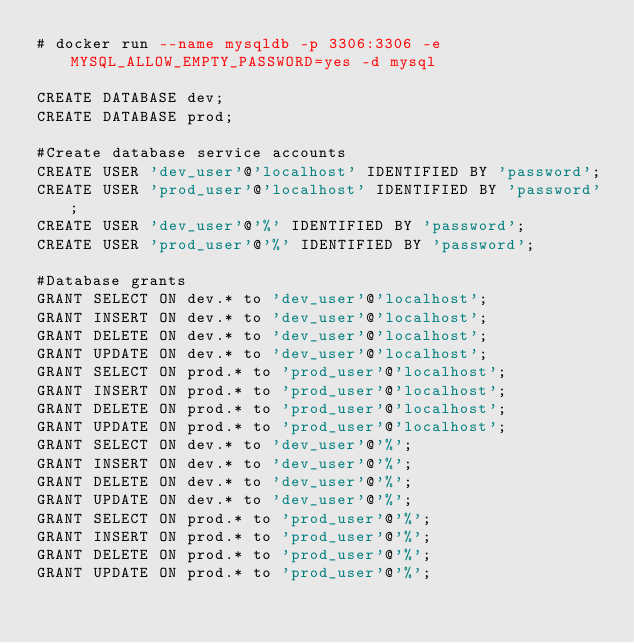<code> <loc_0><loc_0><loc_500><loc_500><_SQL_># docker run --name mysqldb -p 3306:3306 -e MYSQL_ALLOW_EMPTY_PASSWORD=yes -d mysql

CREATE DATABASE dev;
CREATE DATABASE prod;

#Create database service accounts
CREATE USER 'dev_user'@'localhost' IDENTIFIED BY 'password';
CREATE USER 'prod_user'@'localhost' IDENTIFIED BY 'password';
CREATE USER 'dev_user'@'%' IDENTIFIED BY 'password';
CREATE USER 'prod_user'@'%' IDENTIFIED BY 'password';

#Database grants
GRANT SELECT ON dev.* to 'dev_user'@'localhost';
GRANT INSERT ON dev.* to 'dev_user'@'localhost';
GRANT DELETE ON dev.* to 'dev_user'@'localhost';
GRANT UPDATE ON dev.* to 'dev_user'@'localhost';
GRANT SELECT ON prod.* to 'prod_user'@'localhost';
GRANT INSERT ON prod.* to 'prod_user'@'localhost';
GRANT DELETE ON prod.* to 'prod_user'@'localhost';
GRANT UPDATE ON prod.* to 'prod_user'@'localhost';
GRANT SELECT ON dev.* to 'dev_user'@'%';
GRANT INSERT ON dev.* to 'dev_user'@'%';
GRANT DELETE ON dev.* to 'dev_user'@'%';
GRANT UPDATE ON dev.* to 'dev_user'@'%';
GRANT SELECT ON prod.* to 'prod_user'@'%';
GRANT INSERT ON prod.* to 'prod_user'@'%';
GRANT DELETE ON prod.* to 'prod_user'@'%';
GRANT UPDATE ON prod.* to 'prod_user'@'%';</code> 